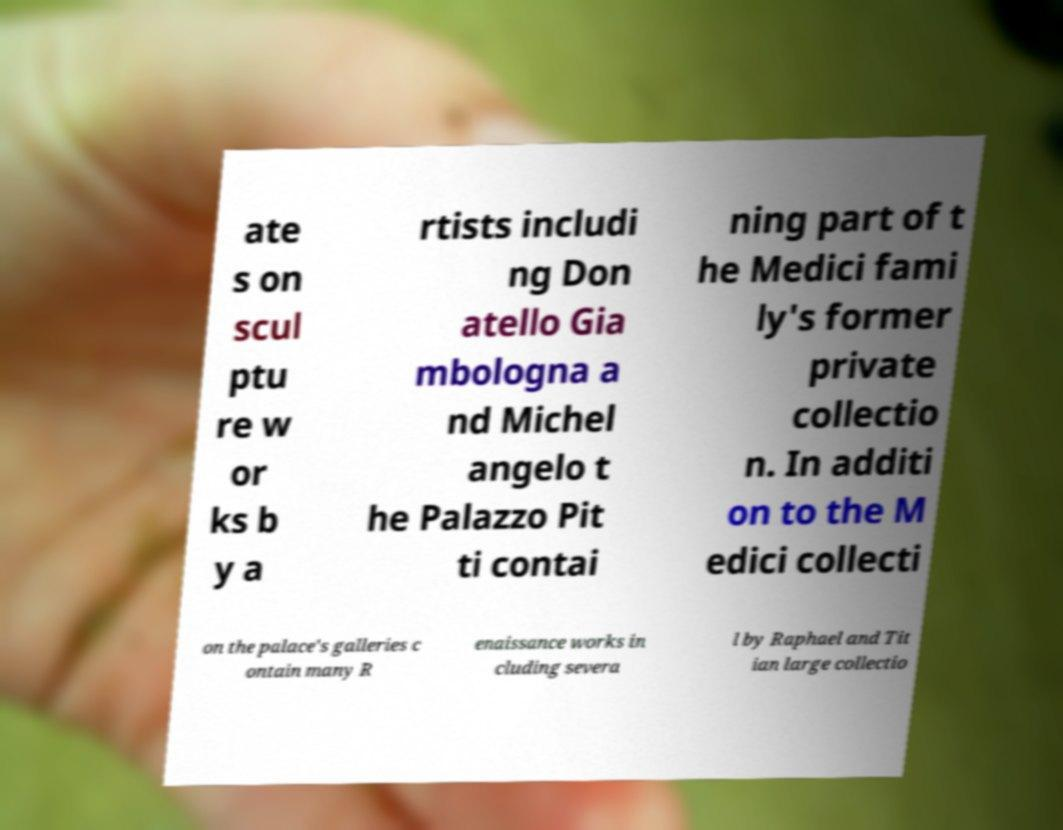Can you accurately transcribe the text from the provided image for me? ate s on scul ptu re w or ks b y a rtists includi ng Don atello Gia mbologna a nd Michel angelo t he Palazzo Pit ti contai ning part of t he Medici fami ly's former private collectio n. In additi on to the M edici collecti on the palace's galleries c ontain many R enaissance works in cluding severa l by Raphael and Tit ian large collectio 